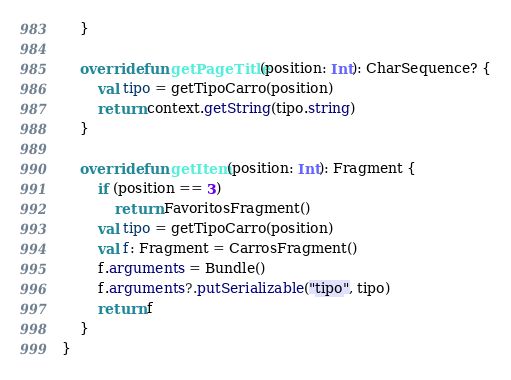<code> <loc_0><loc_0><loc_500><loc_500><_Kotlin_>    }

    override fun getPageTitle(position: Int): CharSequence? {
        val tipo = getTipoCarro(position)
        return context.getString(tipo.string)
    }

    override fun getItem(position: Int): Fragment {
        if (position == 3)
            return FavoritosFragment()
        val tipo = getTipoCarro(position)
        val f: Fragment = CarrosFragment()
        f.arguments = Bundle()
        f.arguments?.putSerializable("tipo", tipo)
        return f
    }
}</code> 